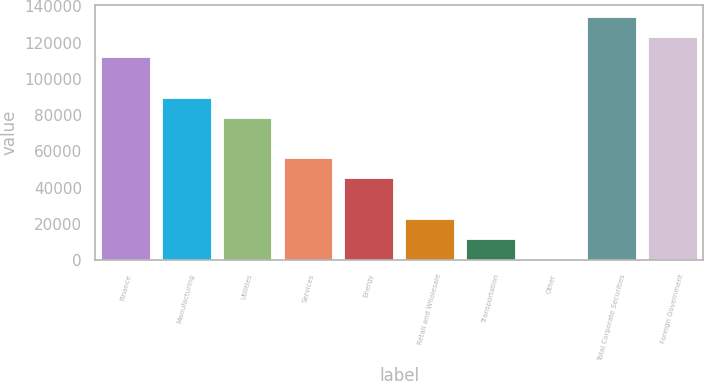Convert chart. <chart><loc_0><loc_0><loc_500><loc_500><bar_chart><fcel>Finance<fcel>Manufacturing<fcel>Utilities<fcel>Services<fcel>Energy<fcel>Retail and Wholesale<fcel>Transportation<fcel>Other<fcel>Total Corporate Securities<fcel>Foreign Government<nl><fcel>111929<fcel>89655.8<fcel>78519.2<fcel>56246<fcel>45109.4<fcel>22836.2<fcel>11699.6<fcel>563<fcel>134202<fcel>123066<nl></chart> 